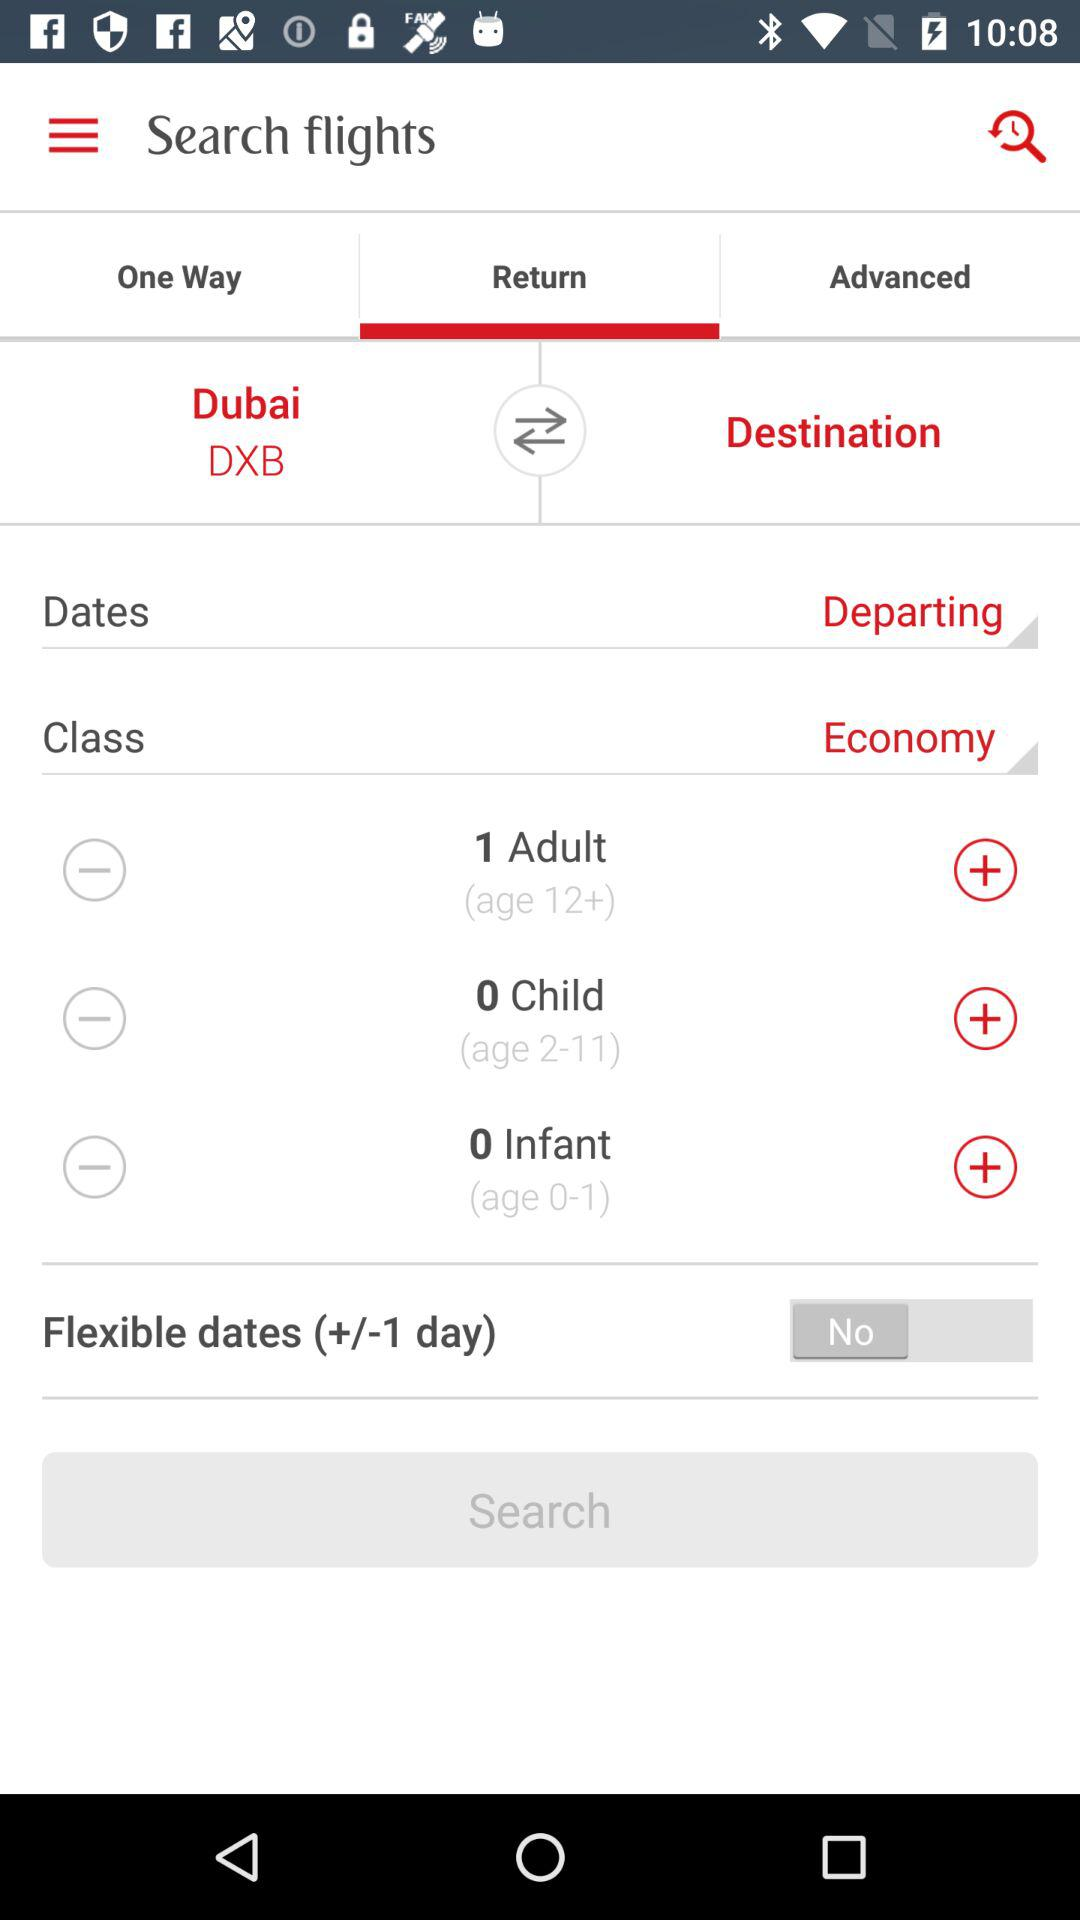How many days of flexibility are available for the selected dates?
Answer the question using a single word or phrase. +/-1 day 